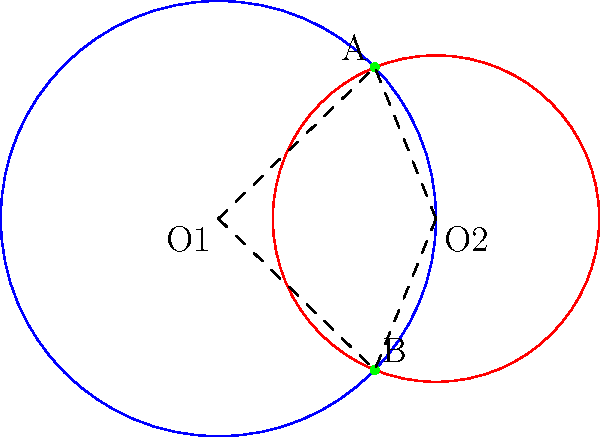Consider two circles representing the critical reception of an original foreign film (blue) and its Hollywood remake (red). The intersection points A and B represent shared themes or elements. If the line segment connecting the centers (O1 and O2) has length 2, and the radii of the original film circle and remake circle are 2 and 1.5 respectively, what is the length of the common chord AB? Let's approach this step-by-step:

1) First, we need to find the distance between the intersection points A and B. This is the length of the common chord.

2) In circle geometry, there's a theorem that states: If two circles intersect, the line joining their centers is perpendicular to the common chord and bisects it.

3) Let's call the midpoint of AB as M. We know that O1M is perpendicular to AB.

4) We can use the Pythagorean theorem in the right triangle O1MA:

   $$O1A^2 = O1M^2 + MA^2$$

5) We know O1A is the radius of the larger circle, so O1A = 2.

6) To find O1M, we can use the formula for the distance between the center of a circle and the chord:

   $$O1M^2 = O1O2^2 + O2M^2 - r2^2$$

   Where O1O2 = 2 (given), r2 = 1.5 (radius of smaller circle)

7) $$O1M^2 = 2^2 + O2M^2 - 1.5^2$$
   $$O1M^2 = 4 + O2M^2 - 2.25 = 1.75 + O2M^2$$

8) We can find O2M using the Pythagorean theorem in the right triangle O2MA:

   $$1.5^2 = O2M^2 + MA^2$$
   $$2.25 = O2M^2 + MA^2$$

9) Substituting this into the equation for O1M:

   $$O1M^2 = 1.75 + (2.25 - MA^2) = 4 - MA^2$$

10) Now we can solve for MA:

    $$4 = 2^2 = O1A^2 = O1M^2 + MA^2 = (4 - MA^2) + MA^2 = 4$$

11) This checks out. Now we know that MA = 1 (half of the common chord).

12) Therefore, the full length of AB is 2.
Answer: 2 